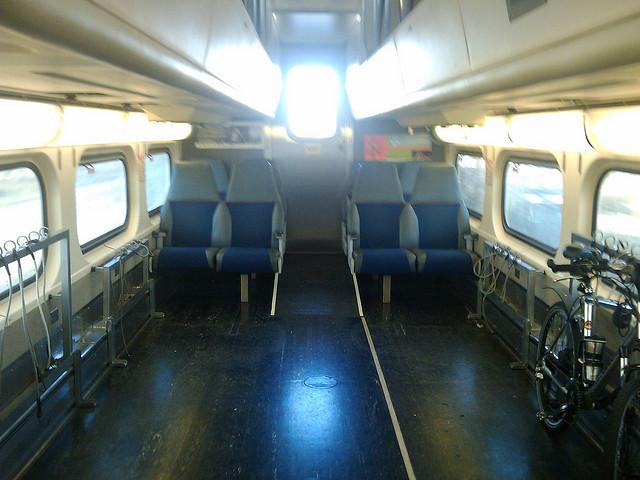What other mode of transportation is in the photo?
Short answer required. Bike. How many people are on the train?
Short answer required. 0. How many seats are on the bus?
Write a very short answer. 8. Is this train efficient?
Keep it brief. Yes. What is the train stopped next to?
Be succinct. Station. 